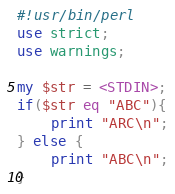Convert code to text. <code><loc_0><loc_0><loc_500><loc_500><_Perl_>#!usr/bin/perl
use strict;
use warnings;

my $str = <STDIN>;
if($str eq "ABC"){
    print "ARC\n";
} else {
    print "ABC\n";
}
</code> 